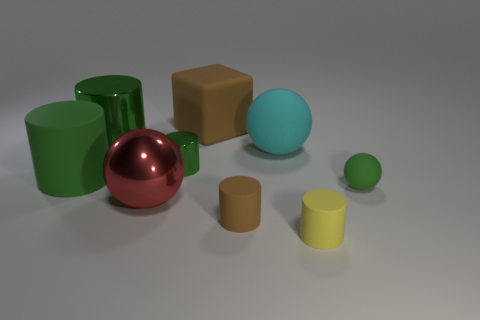There is a tiny cylinder that is the same color as the big matte cube; what material is it?
Your response must be concise. Rubber. What is the shape of the brown matte thing that is the same size as the green matte cylinder?
Make the answer very short. Cube. Is the material of the small brown thing the same as the yellow cylinder?
Provide a short and direct response. Yes. How many rubber things are either small red cylinders or red balls?
Your answer should be very brief. 0. There is a rubber object that is the same color as the big matte cylinder; what is its shape?
Ensure brevity in your answer.  Sphere. Is the color of the big rubber thing that is left of the big brown object the same as the rubber cube?
Provide a succinct answer. No. What is the shape of the metal object in front of the tiny green thing in front of the large green rubber thing?
Your answer should be compact. Sphere. What number of things are either cylinders that are behind the red sphere or big objects to the right of the large matte cylinder?
Offer a very short reply. 6. What is the shape of the large cyan thing that is made of the same material as the yellow cylinder?
Ensure brevity in your answer.  Sphere. Is there any other thing that has the same color as the tiny sphere?
Give a very brief answer. Yes. 